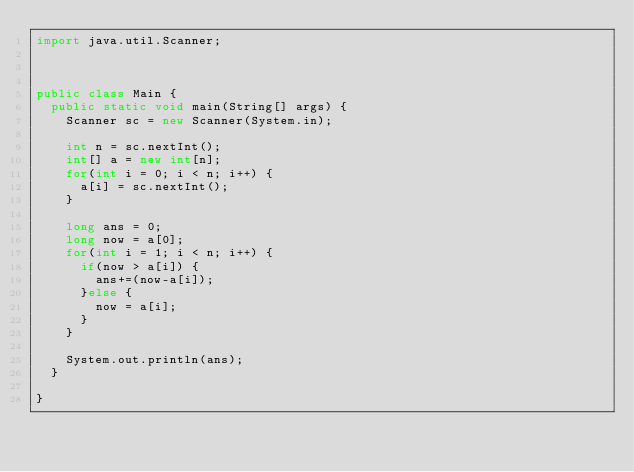Convert code to text. <code><loc_0><loc_0><loc_500><loc_500><_Java_>import java.util.Scanner;



public class Main {
	public static void main(String[] args) {
		Scanner sc = new Scanner(System.in);
	
		int n = sc.nextInt();
		int[] a = new int[n];
		for(int i = 0; i < n; i++) {
			a[i] = sc.nextInt();
		}
		
		long ans = 0;
		long now = a[0];
		for(int i = 1; i < n; i++) {
			if(now > a[i]) {
				ans+=(now-a[i]);
			}else {
				now = a[i];
			}
		}
		
		System.out.println(ans);
	}
	
}

</code> 